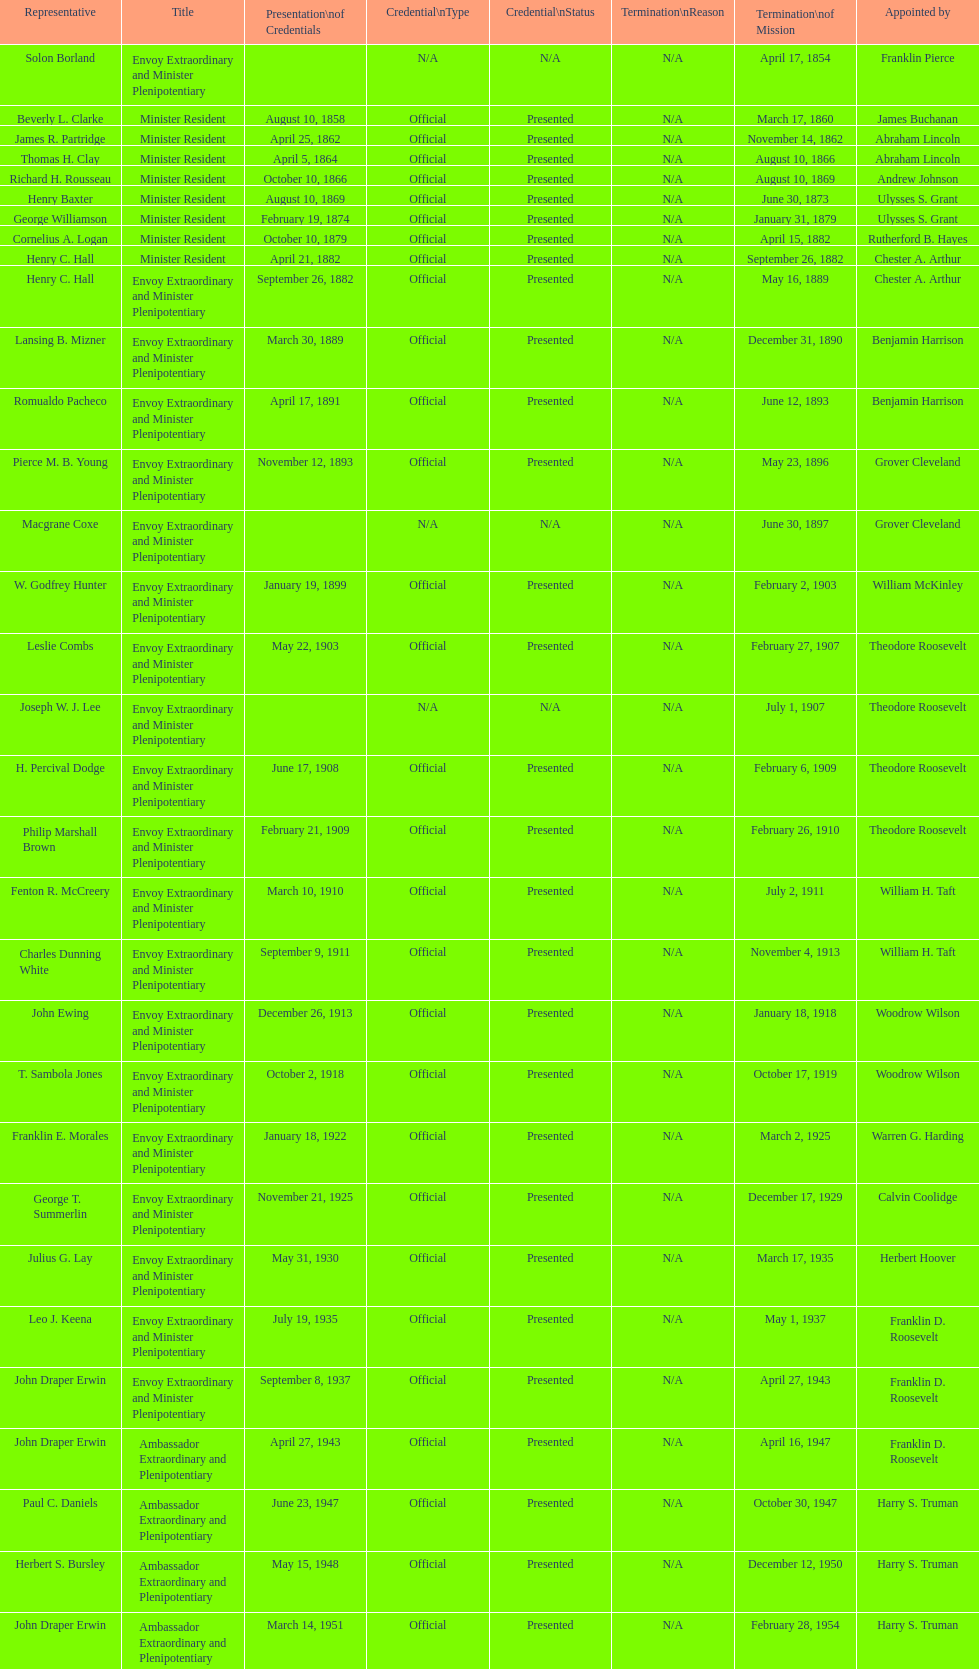Who was the last representative picked? Lisa Kubiske. 